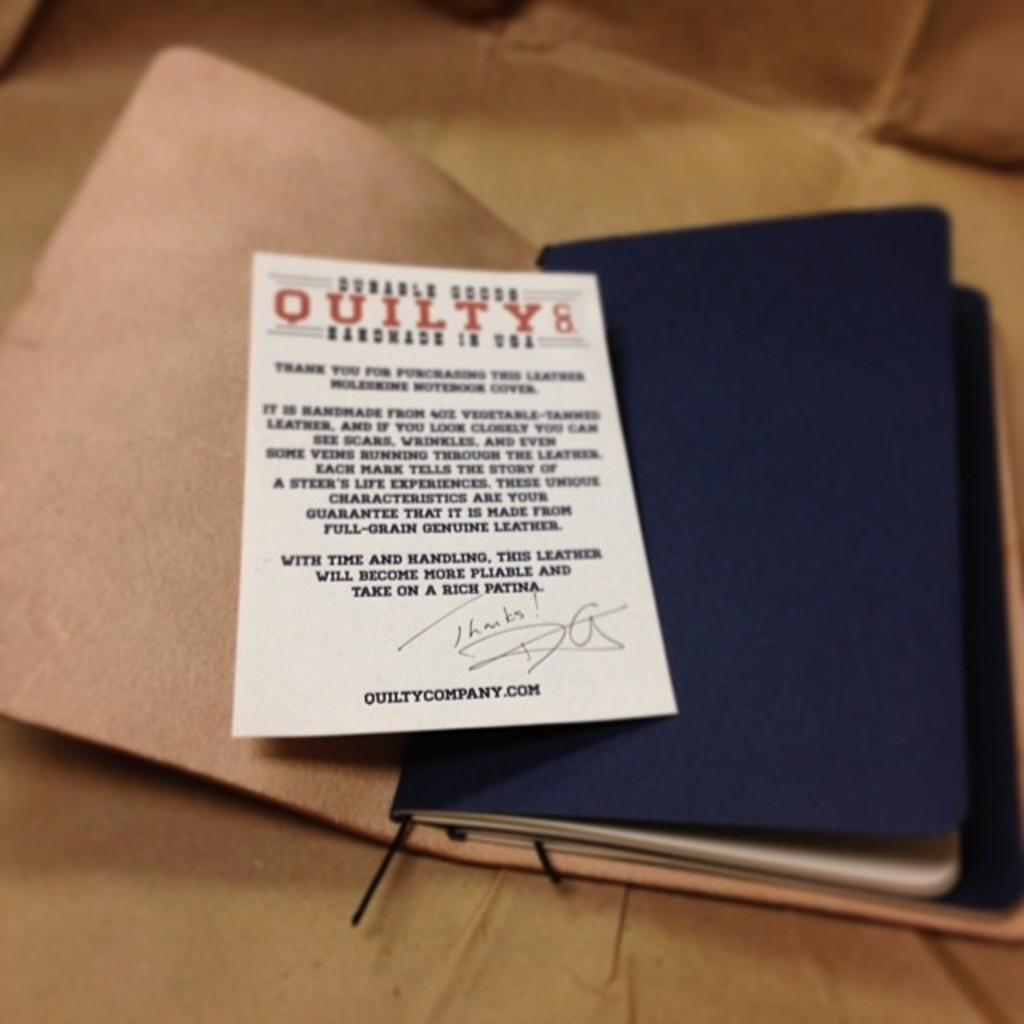Provide a one-sentence caption for the provided image. a notebook with a note about Quilty inside it. 